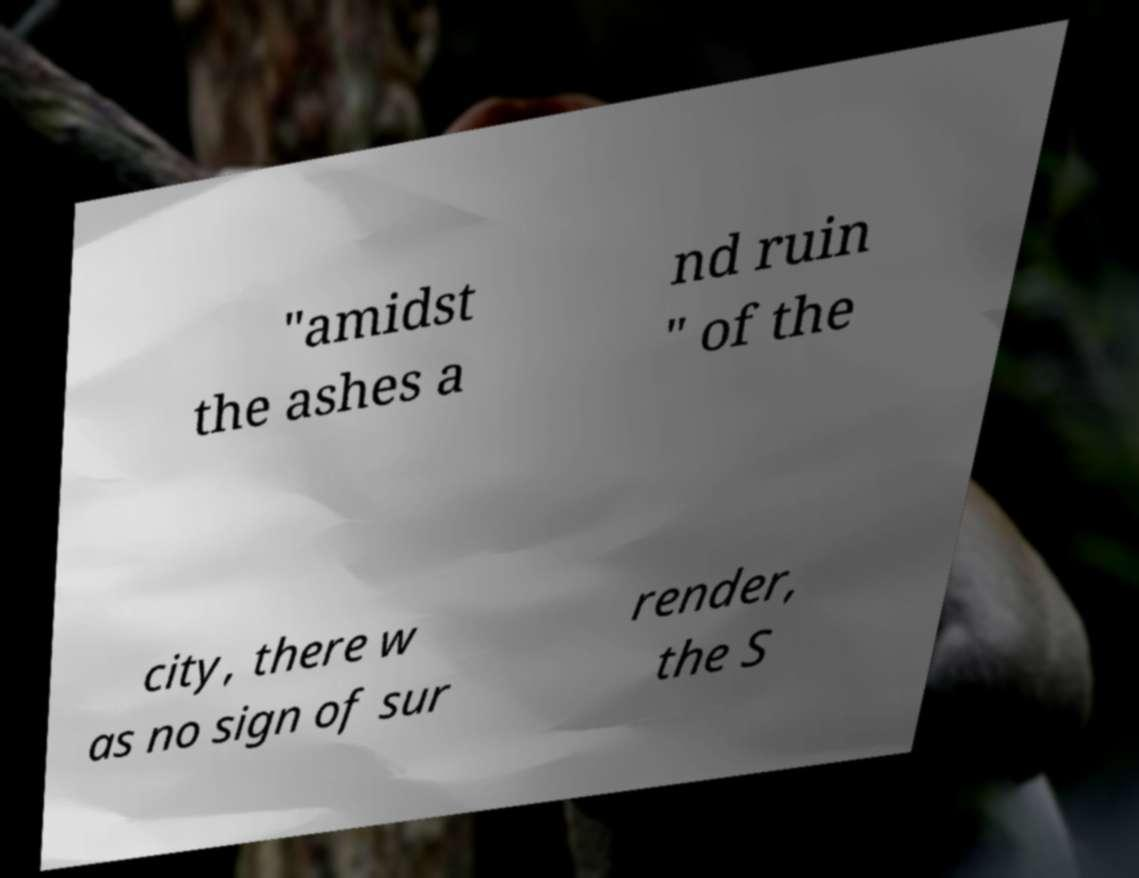I need the written content from this picture converted into text. Can you do that? "amidst the ashes a nd ruin " of the city, there w as no sign of sur render, the S 